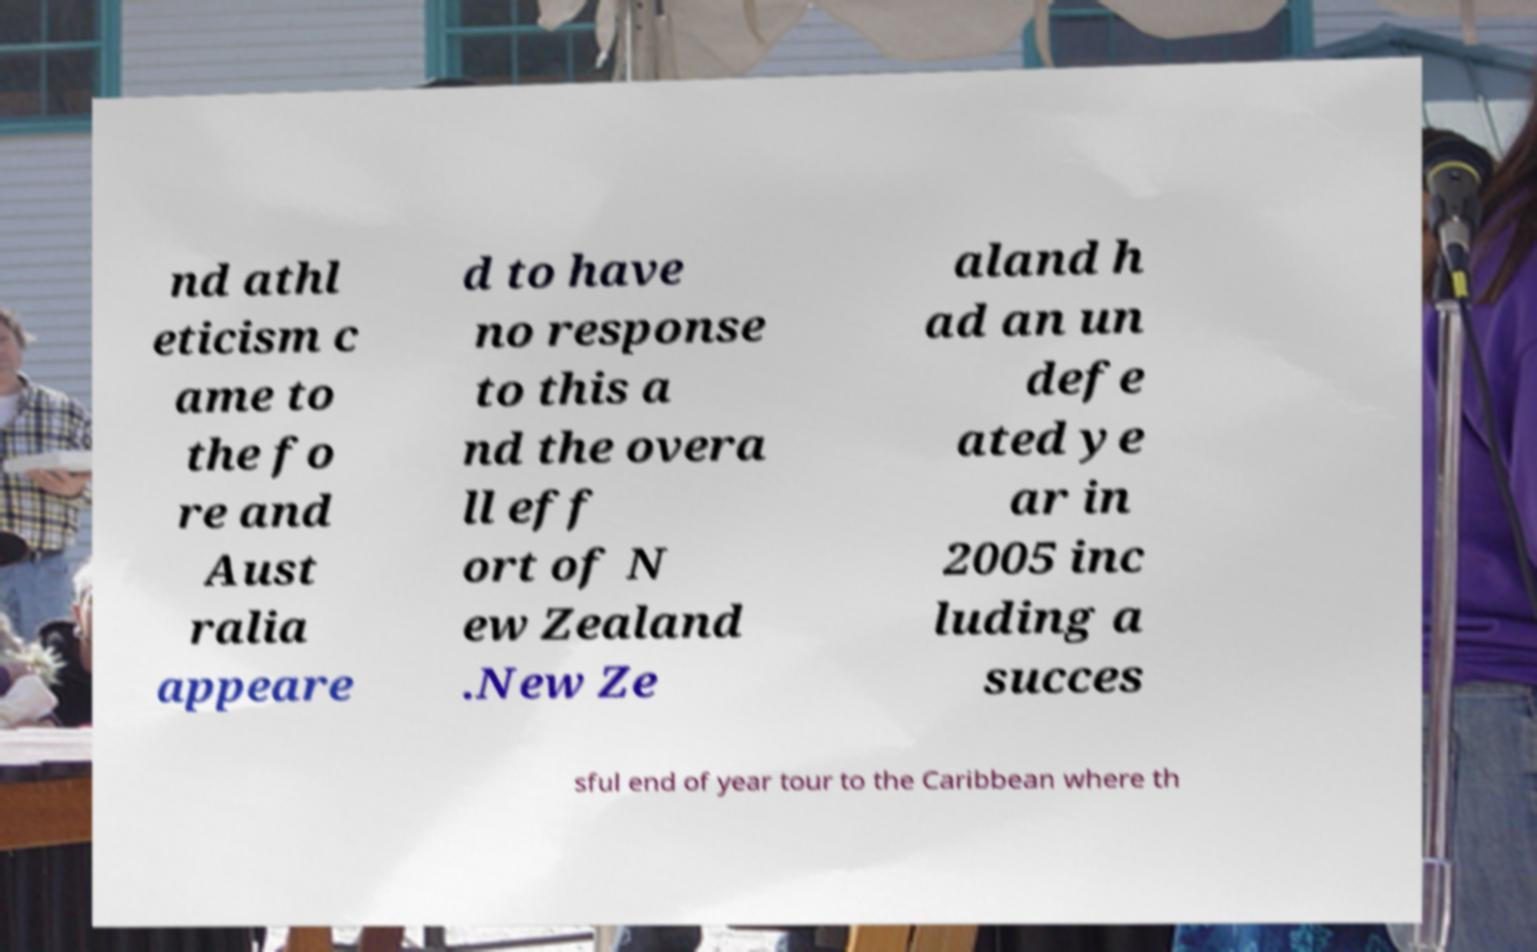Can you read and provide the text displayed in the image?This photo seems to have some interesting text. Can you extract and type it out for me? nd athl eticism c ame to the fo re and Aust ralia appeare d to have no response to this a nd the overa ll eff ort of N ew Zealand .New Ze aland h ad an un defe ated ye ar in 2005 inc luding a succes sful end of year tour to the Caribbean where th 